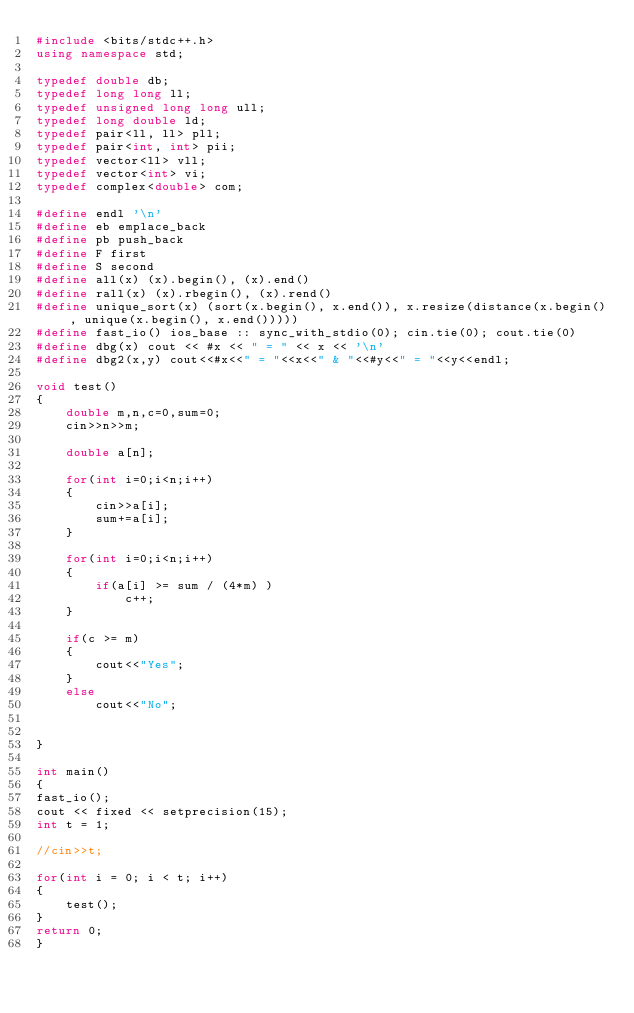<code> <loc_0><loc_0><loc_500><loc_500><_C++_>#include <bits/stdc++.h>
using namespace std;

typedef double db;
typedef long long ll;
typedef unsigned long long ull;
typedef long double ld;
typedef pair<ll, ll> pll;
typedef pair<int, int> pii;
typedef vector<ll> vll;
typedef vector<int> vi;
typedef complex<double> com;

#define endl '\n'
#define eb emplace_back
#define pb push_back
#define F first
#define S second
#define all(x) (x).begin(), (x).end()
#define rall(x) (x).rbegin(), (x).rend()
#define unique_sort(x) (sort(x.begin(), x.end()), x.resize(distance(x.begin(), unique(x.begin(), x.end()))))
#define fast_io() ios_base :: sync_with_stdio(0); cin.tie(0); cout.tie(0)
#define dbg(x) cout << #x << " = " << x << '\n'
#define dbg2(x,y) cout<<#x<<" = "<<x<<" & "<<#y<<" = "<<y<<endl;

void test()
{
	double m,n,c=0,sum=0;
	cin>>n>>m;

	double a[n];

	for(int i=0;i<n;i++)
	{
		cin>>a[i];
		sum+=a[i];
	}

	for(int i=0;i<n;i++)
	{
		if(a[i] >= sum / (4*m) )
			c++;
	}

	if(c >= m)
	{
		cout<<"Yes";
	}
	else
		cout<<"No";


}

int main()
{   
fast_io();
cout << fixed << setprecision(15);
int t = 1;

//cin>>t;

for(int i = 0; i < t; i++)
{
	test();
}
return 0;
}</code> 